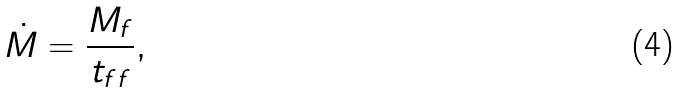Convert formula to latex. <formula><loc_0><loc_0><loc_500><loc_500>\dot { M } = \frac { M _ { f } } { t _ { f f } } ,</formula> 